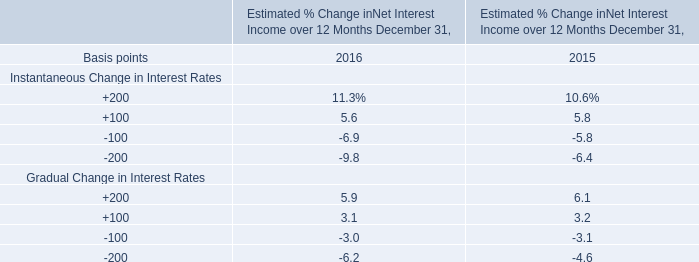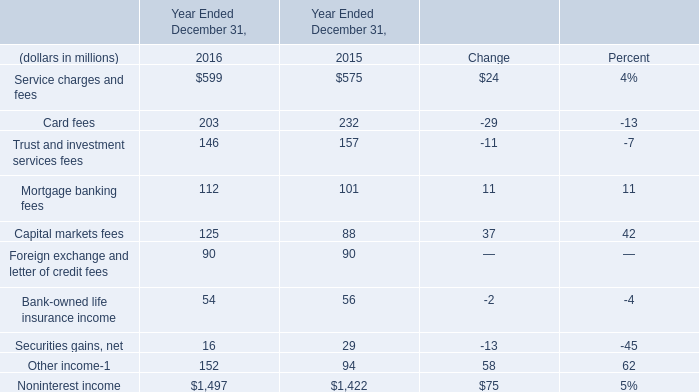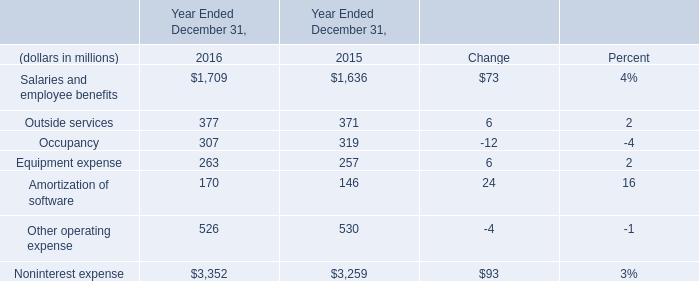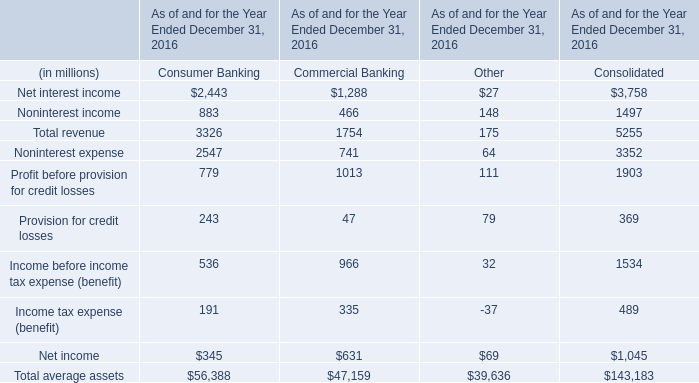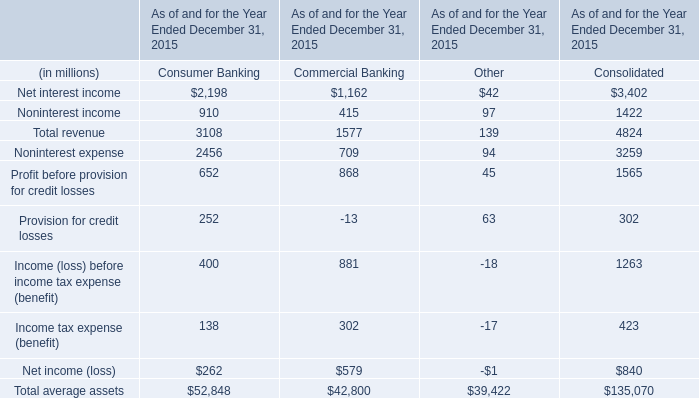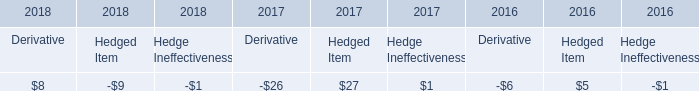What is the sum of Salaries and employee benefits, Outside services and Occupancy in 2016? (in million) 
Computations: ((1709 + 377) + 307)
Answer: 2393.0. 